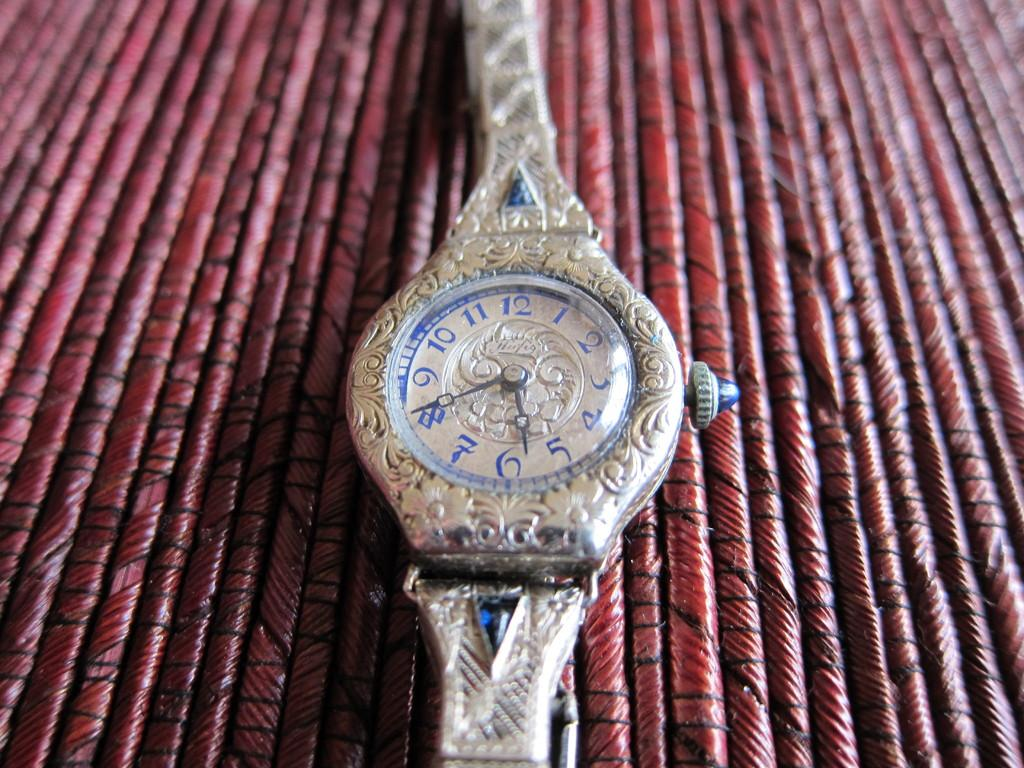<image>
Share a concise interpretation of the image provided. An intricately carved silver ladie's watch by Herfig. 